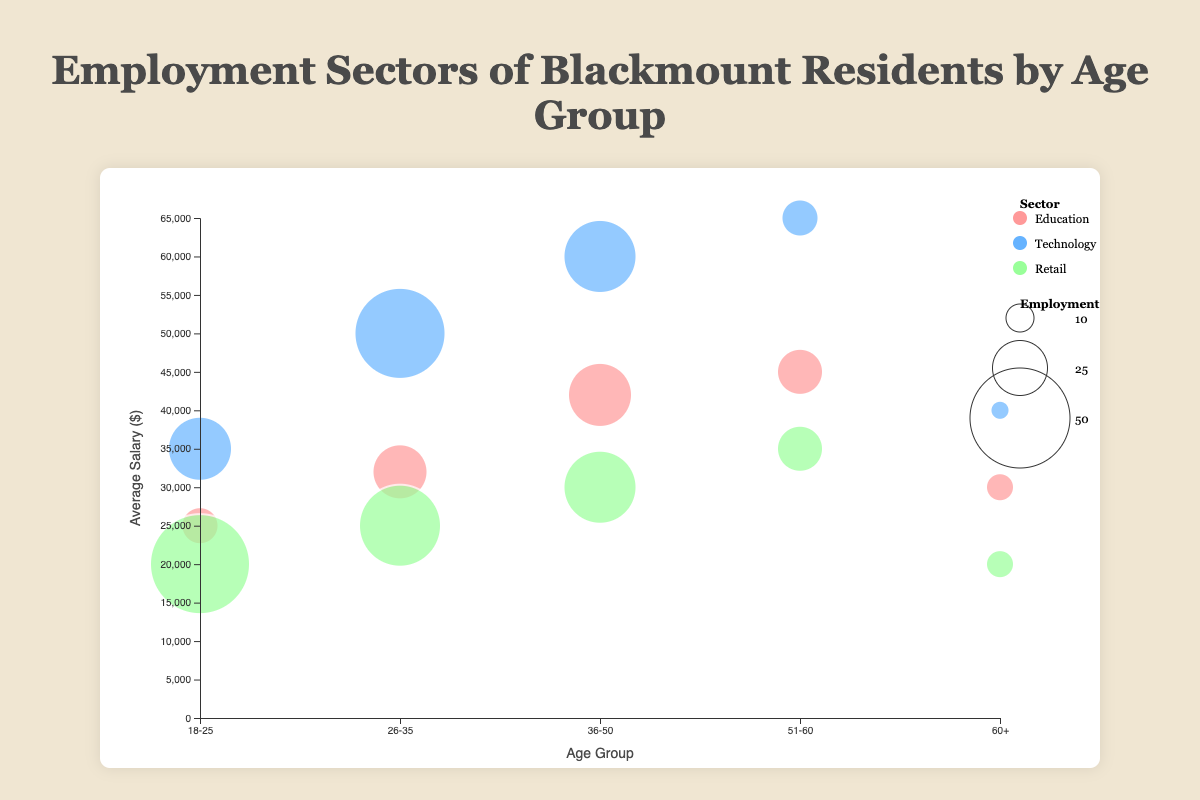What is the title of the chart? The title of the chart is displayed at the top and is meant to describe the content and purpose of the chart.
Answer: Employment Sectors of Blackmount Residents by Age Group What does the vertical axis represent? The vertical axis is labeled to represent the measure it is displaying, in this case, the average salary in dollars.
Answer: Average Salary ($) Which age group has the highest average salary in the Technology sector? Look for the circle corresponding to the Technology sector across age groups and identify the one highest on the vertical axis.
Answer: 51-60 How many age groups are represented in the chart? Count the distinct markers or labels on the horizontal axis indicating different age groups.
Answer: 5 What color is used to represent the Retail sector in the chart? Identify the color associated with the Retail sector in the legend.
Answer: Light Green Which sector has the largest bubble in the 18-25 age group? Locate the age group 18-25 on the horizontal axis and identify which bubble has the largest radius, representing the highest employment count.
Answer: Retail What is the range of average salaries for the Education sector? Locate the bubbles corresponding to the Education sector and note the positions on the vertical axis. The range is from the lowest to the highest point.
Answer: 25000 to 45000 Compare the employment counts for Retail and Technology sectors in the 26-35 age group. Which is higher? Find the bubbles for both Retail and Technology sectors in the 26-35 age group and compare their sizes to determine which is larger.
Answer: Technology Which age group has the smallest employment bubble in any sector and what is the sector? Identify the smallest bubble across all sectors and age groups by judging the radius size.
Answer: 60+, Technology What is the average salary difference between the Education and Retail sectors for the 51-60 age group? Locate the bubbles for the Education and Retail sectors within the 51-60 age group and subtract the average salary of the Retail sector from the Education sector.
Answer: 10000 